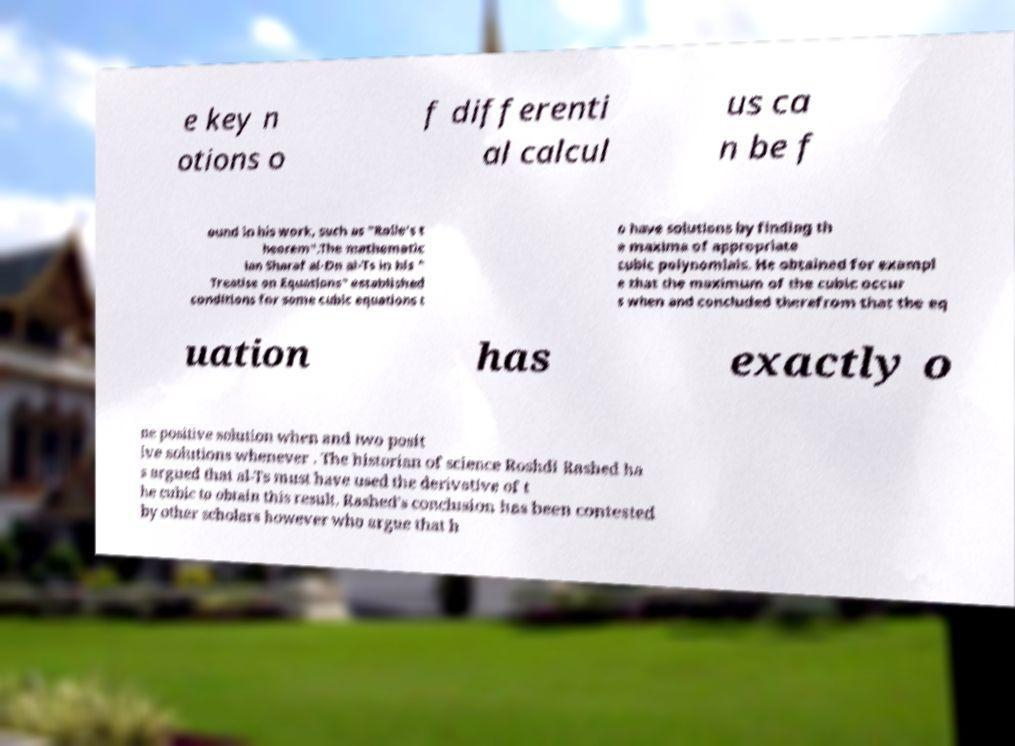I need the written content from this picture converted into text. Can you do that? e key n otions o f differenti al calcul us ca n be f ound in his work, such as "Rolle's t heorem".The mathematic ian Sharaf al-Dn al-Ts in his " Treatise on Equations" established conditions for some cubic equations t o have solutions by finding th e maxima of appropriate cubic polynomials. He obtained for exampl e that the maximum of the cubic occur s when and concluded therefrom that the eq uation has exactly o ne positive solution when and two posit ive solutions whenever . The historian of science Roshdi Rashed ha s argued that al-Ts must have used the derivative of t he cubic to obtain this result. Rashed's conclusion has been contested by other scholars however who argue that h 